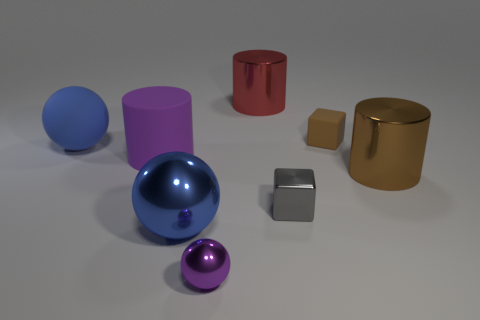Subtract all green cylinders. Subtract all purple balls. How many cylinders are left? 3 Add 1 large things. How many objects exist? 9 Subtract all cylinders. How many objects are left? 5 Subtract 1 red cylinders. How many objects are left? 7 Subtract all big purple matte objects. Subtract all large brown cylinders. How many objects are left? 6 Add 7 small matte blocks. How many small matte blocks are left? 8 Add 4 tiny balls. How many tiny balls exist? 5 